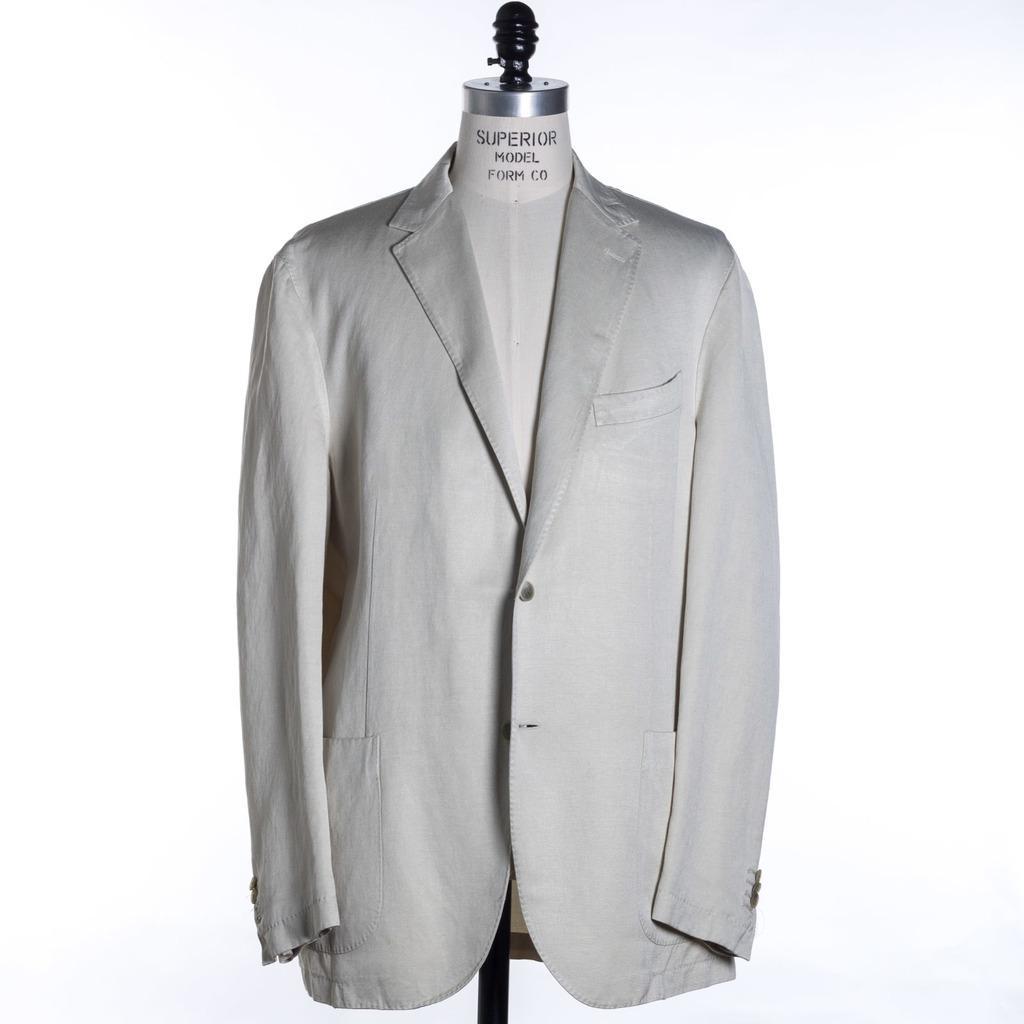In one or two sentences, can you explain what this image depicts? There is a coat on a mannequin in the center of the image. 